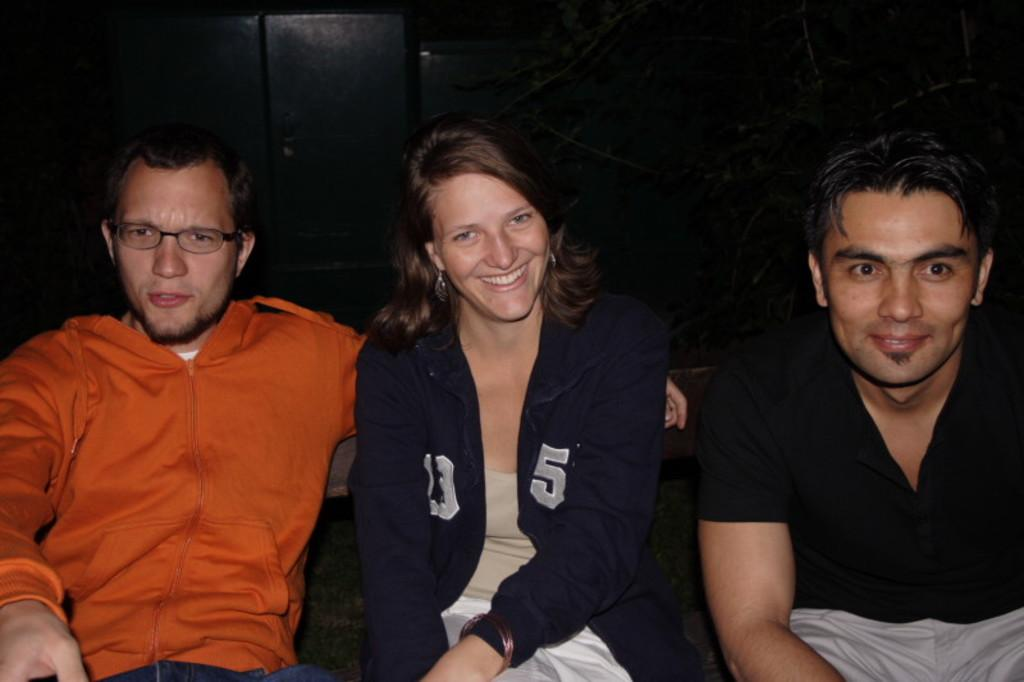How many people are in the image? There are two men and a woman in the image. What is the woman doing in the image? The woman is smiling. Can you describe one of the men in the image? One of the men is wearing spectacles. What can be said about the background of the image? The background of the image is dark. What type of poison is the woman holding in the image? There is no poison present in the image; the woman is simply smiling. What does the porter do in the image? There is no porter present in the image. 